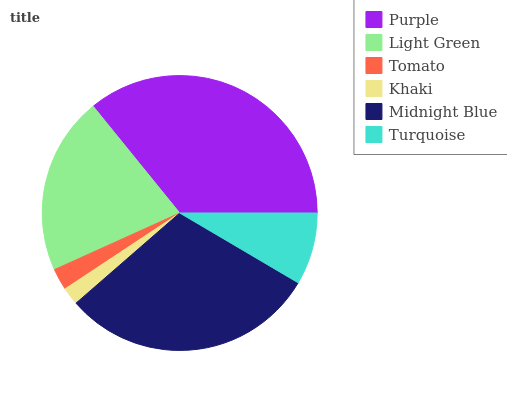Is Khaki the minimum?
Answer yes or no. Yes. Is Purple the maximum?
Answer yes or no. Yes. Is Light Green the minimum?
Answer yes or no. No. Is Light Green the maximum?
Answer yes or no. No. Is Purple greater than Light Green?
Answer yes or no. Yes. Is Light Green less than Purple?
Answer yes or no. Yes. Is Light Green greater than Purple?
Answer yes or no. No. Is Purple less than Light Green?
Answer yes or no. No. Is Light Green the high median?
Answer yes or no. Yes. Is Turquoise the low median?
Answer yes or no. Yes. Is Khaki the high median?
Answer yes or no. No. Is Tomato the low median?
Answer yes or no. No. 